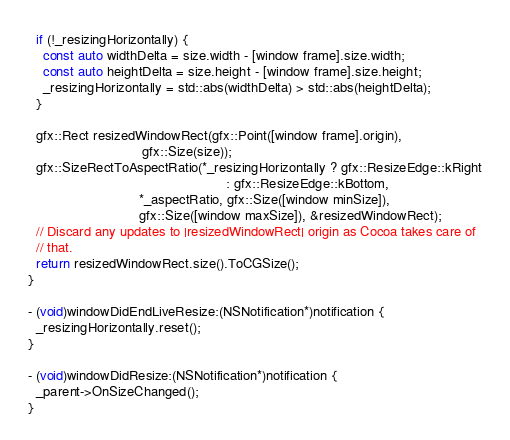Convert code to text. <code><loc_0><loc_0><loc_500><loc_500><_ObjectiveC_>
  if (!_resizingHorizontally) {
    const auto widthDelta = size.width - [window frame].size.width;
    const auto heightDelta = size.height - [window frame].size.height;
    _resizingHorizontally = std::abs(widthDelta) > std::abs(heightDelta);
  }

  gfx::Rect resizedWindowRect(gfx::Point([window frame].origin),
                              gfx::Size(size));
  gfx::SizeRectToAspectRatio(*_resizingHorizontally ? gfx::ResizeEdge::kRight
                                                    : gfx::ResizeEdge::kBottom,
                             *_aspectRatio, gfx::Size([window minSize]),
                             gfx::Size([window maxSize]), &resizedWindowRect);
  // Discard any updates to |resizedWindowRect| origin as Cocoa takes care of
  // that.
  return resizedWindowRect.size().ToCGSize();
}

- (void)windowDidEndLiveResize:(NSNotification*)notification {
  _resizingHorizontally.reset();
}

- (void)windowDidResize:(NSNotification*)notification {
  _parent->OnSizeChanged();
}
</code> 